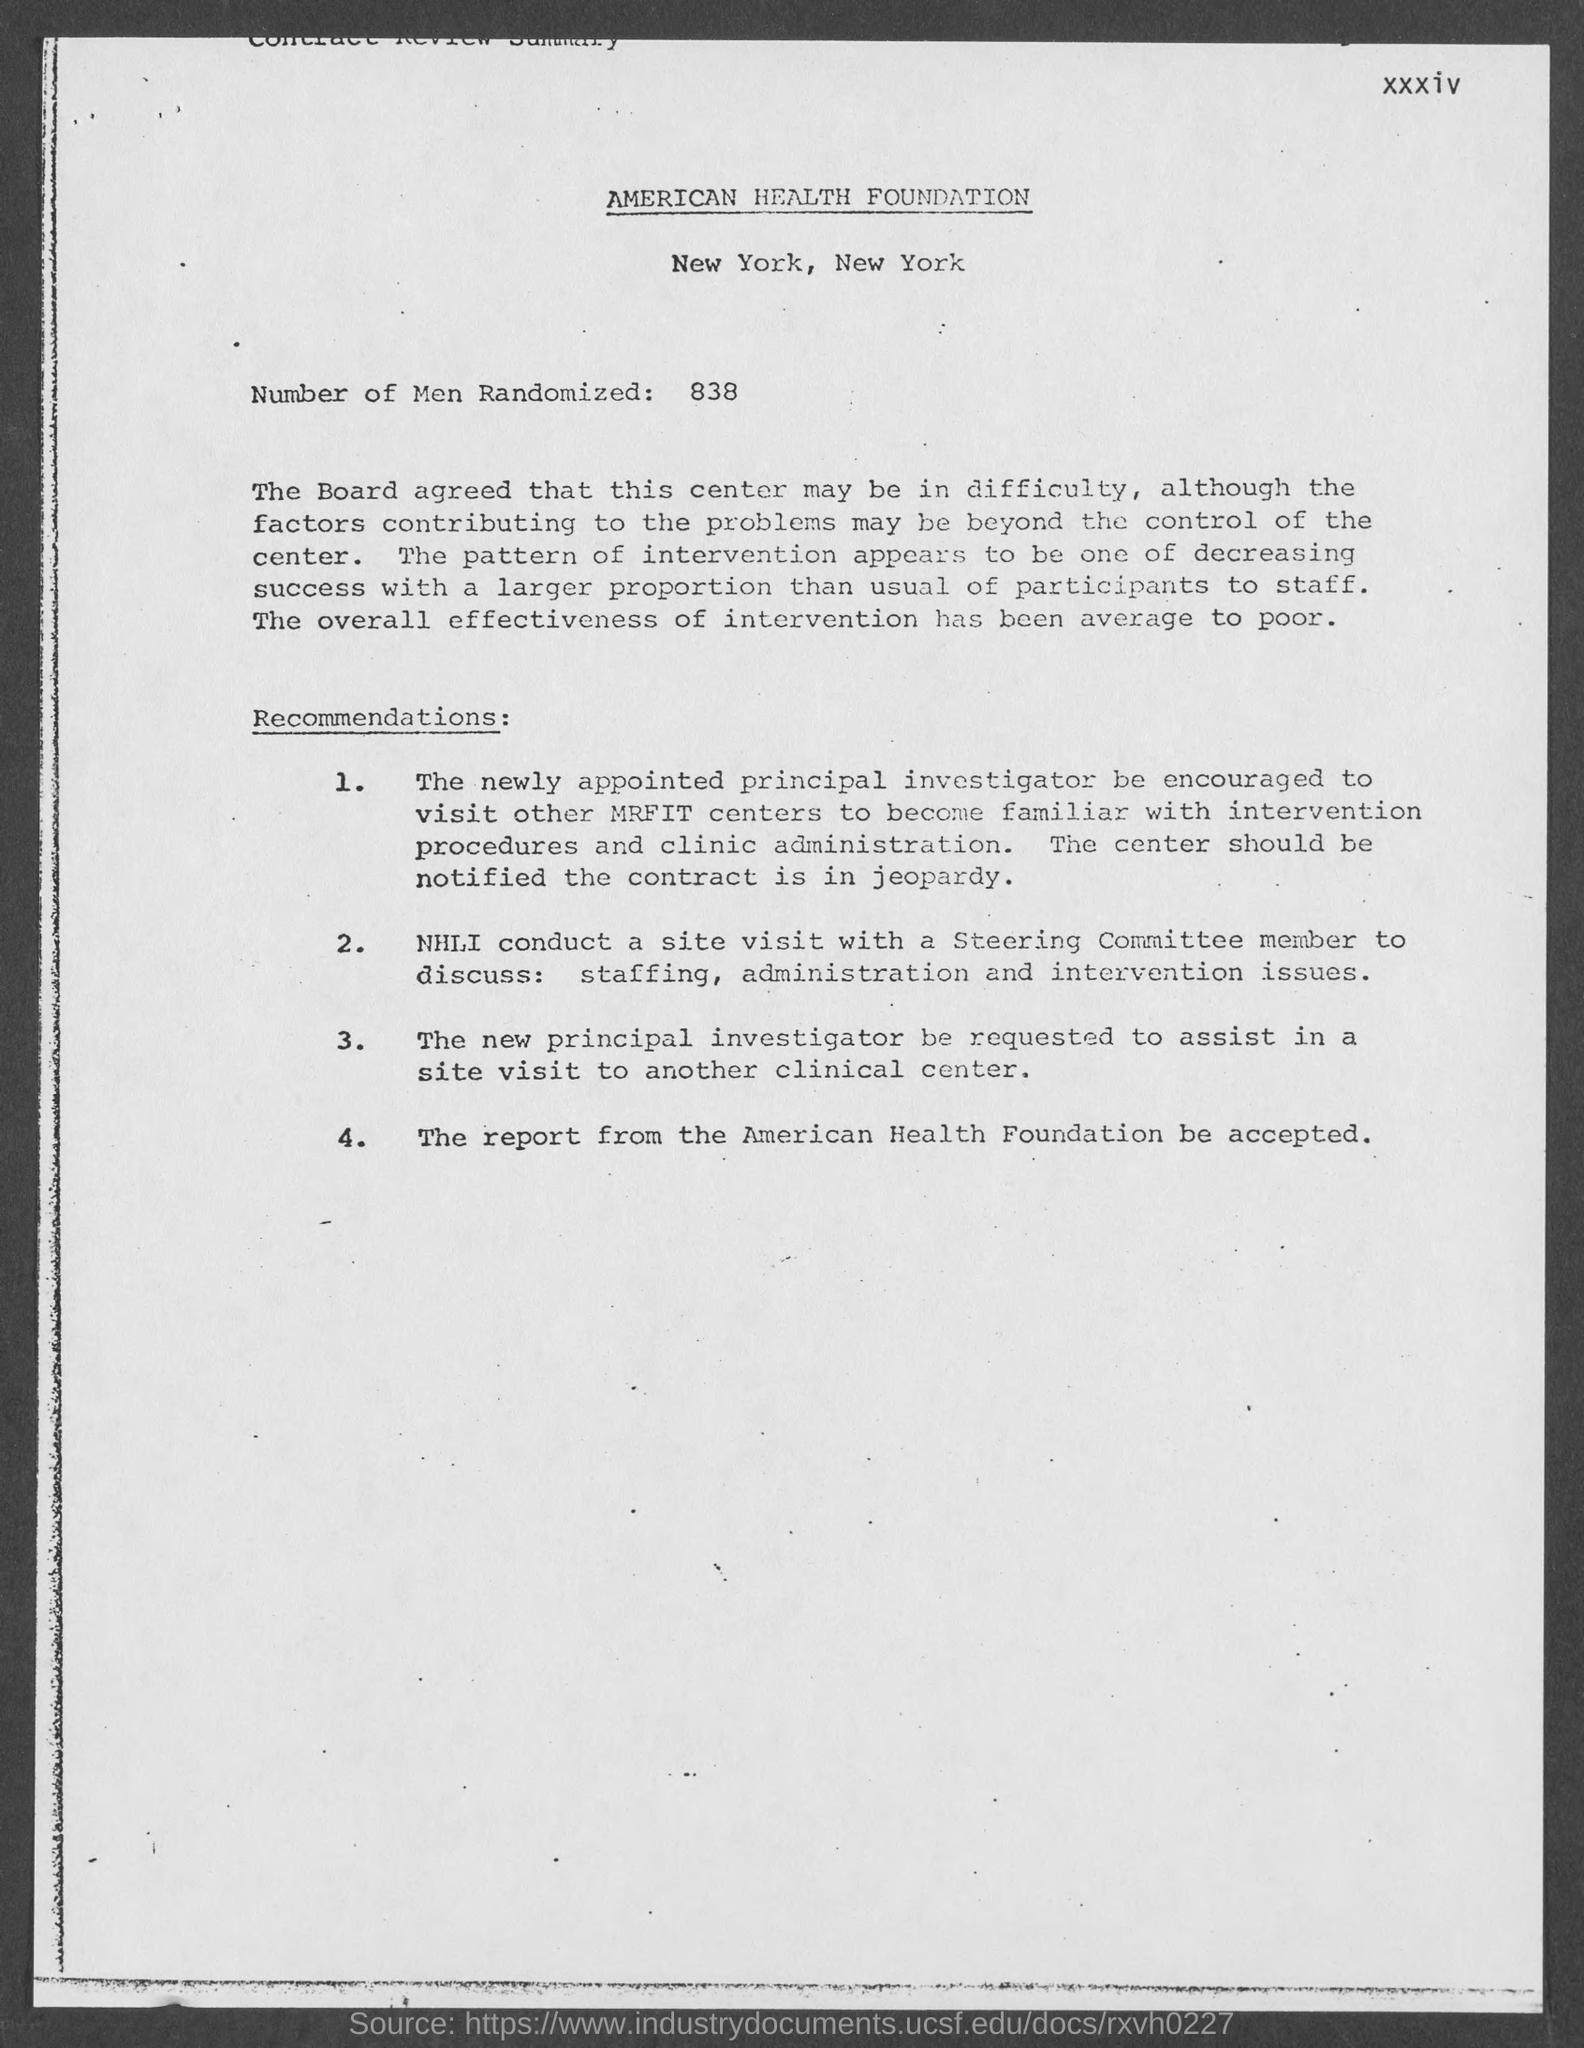Mention a couple of crucial points in this snapshot. 838 individuals were randomly selected for the study. 